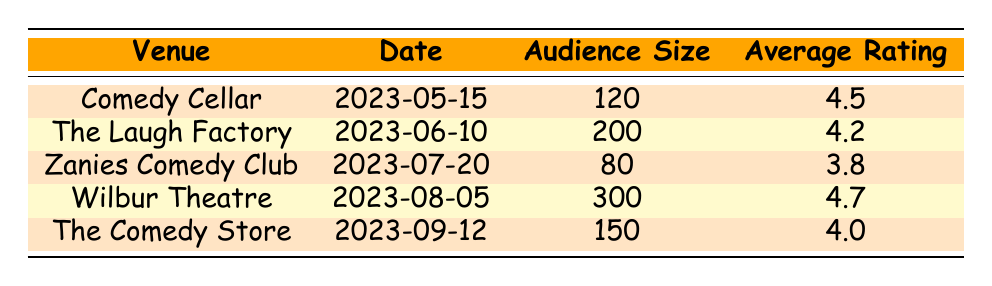What is the venue with the highest average rating? The table shows the average ratings for each venue. Upon reviewing the average ratings, Wilbur Theatre has the highest average rating of 4.7.
Answer: Wilbur Theatre How many audience members attended the performance at The Laugh Factory? According to the table, The Laugh Factory had an audience size of 200 members.
Answer: 200 Is the average rating at Zanies Comedy Club above 4.0? Looking at the average rating for Zanies Comedy Club, which is 3.8, it is clear that it is below 4.0.
Answer: No What is the difference in audience size between the Wilbur Theatre and Zanies Comedy Club? For Wilbur Theatre, the audience size is 300, and for Zanies Comedy Club, it is 80. The difference is calculated as 300 - 80 = 220.
Answer: 220 What is the average rating of all the venues listed? To find the average rating, sum all the average ratings: 4.5 + 4.2 + 3.8 + 4.7 + 4.0 = 21.2. There are 5 venues, so divide by 5: 21.2 / 5 = 4.24.
Answer: 4.24 Did the audience size at The Comedy Store exceed 150? The audience size at The Comedy Store is explicitly listed as 150, which means it did not exceed that number.
Answer: No Which venue had the lowest average rating? A review of the average ratings indicates that Zanies Comedy Club has the lowest average rating of 3.8 among the venues.
Answer: Zanies Comedy Club How many comments were left for the performance at Comedy Cellar? The table indicates that there are three comments listed for the Comedy Cellar performance.
Answer: 3 What is the average audience size across all venues? Sum the audience sizes: 120 + 200 + 80 + 300 + 150 = 850. Then, divide by 5 (the number of venues): 850 / 5 = 170.
Answer: 170 What's the proportion of venues with an average rating of 4.0 or higher? There are 4 venues (Comedy Cellar, The Laugh Factory, Wilbur Theatre, and The Comedy Store) with an average rating of 4.0 or higher, out of 5 total venues. This gives a proportion of 4/5 = 0.8 or 80%.
Answer: 80% 